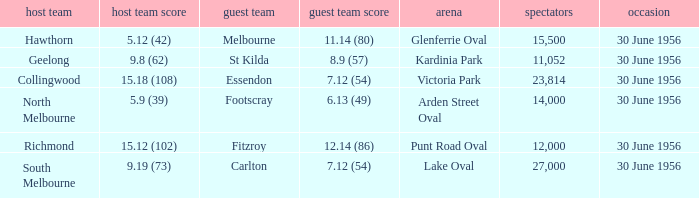What is the home team at Victoria Park with an Away team score of 7.12 (54) and more than 12,000 people? Collingwood. 